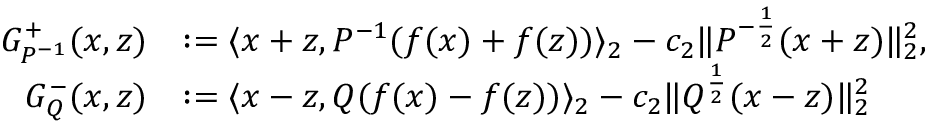<formula> <loc_0><loc_0><loc_500><loc_500>\begin{array} { r l } { G _ { P ^ { - 1 } } ^ { + } ( x , z ) } & { \colon = \langle x + z , P ^ { - 1 } ( f ( x ) + f ( z ) ) \rangle _ { 2 } - c _ { 2 } \| P ^ { - \frac { 1 } { 2 } } ( x + z ) \| _ { 2 } ^ { 2 } , } \\ { G _ { Q } ^ { - } ( x , z ) } & { \colon = \langle x - z , Q ( f ( x ) - f ( z ) ) \rangle _ { 2 } - c _ { 2 } \| Q ^ { \frac { 1 } { 2 } } ( x - z ) \| _ { 2 } ^ { 2 } } \end{array}</formula> 